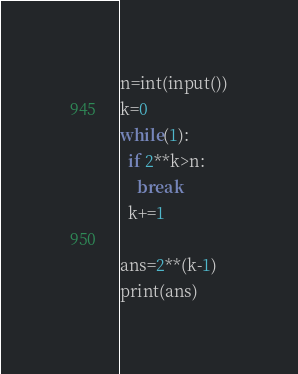<code> <loc_0><loc_0><loc_500><loc_500><_Python_>n=int(input())
k=0
while(1):
  if 2**k>n:
    break
  k+=1

ans=2**(k-1)
print(ans)</code> 